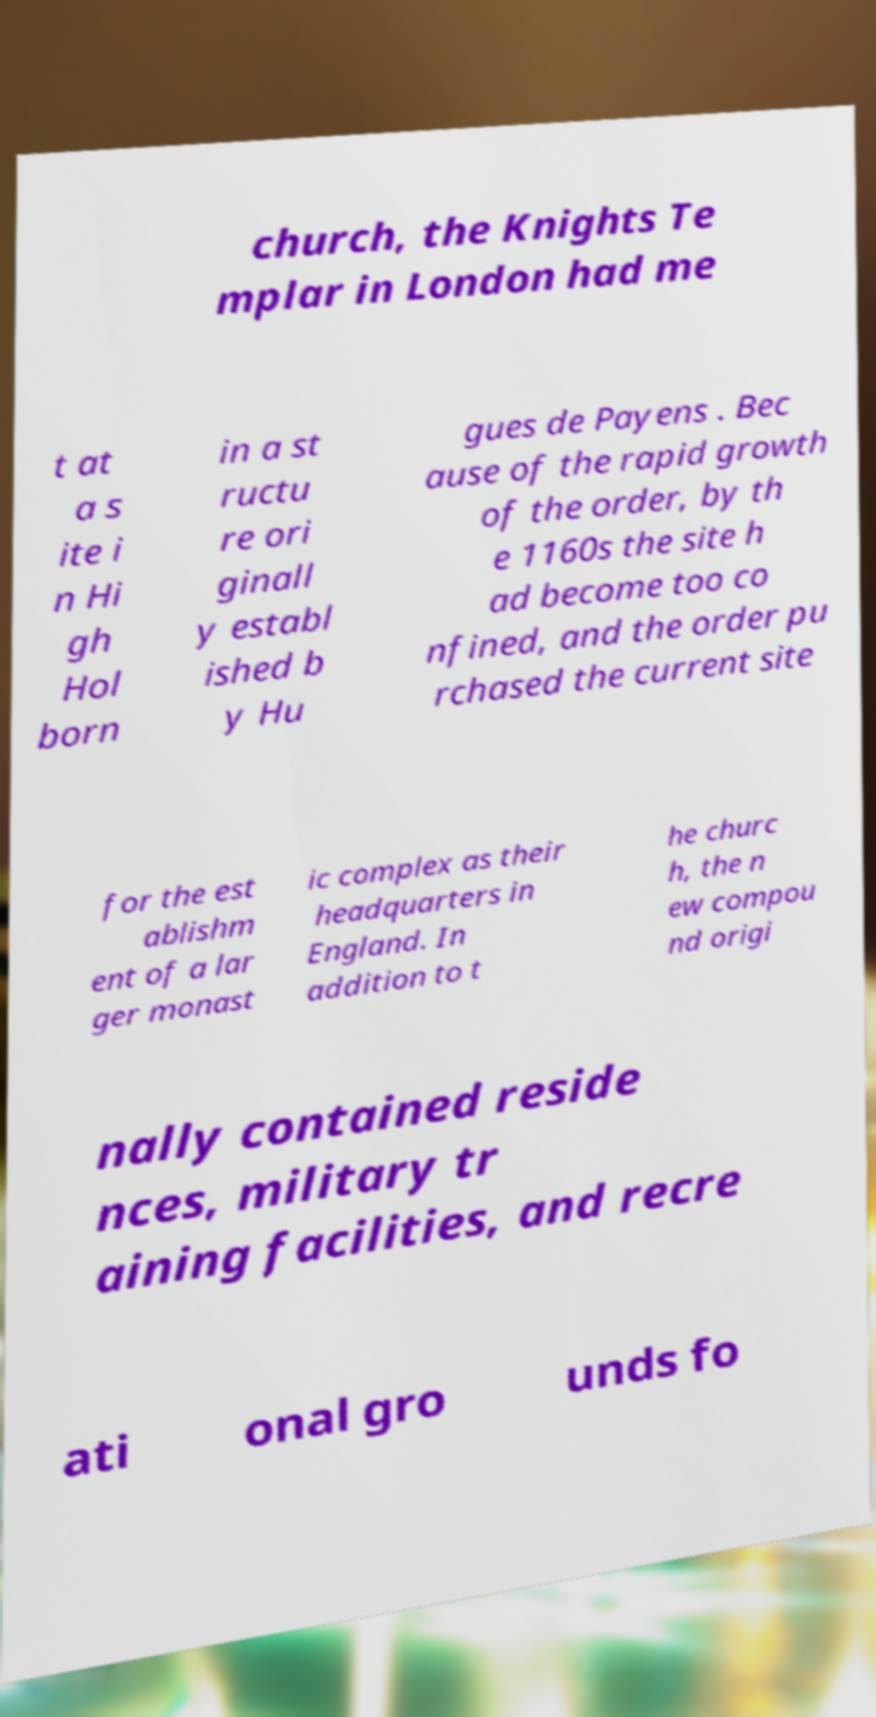Please read and relay the text visible in this image. What does it say? church, the Knights Te mplar in London had me t at a s ite i n Hi gh Hol born in a st ructu re ori ginall y establ ished b y Hu gues de Payens . Bec ause of the rapid growth of the order, by th e 1160s the site h ad become too co nfined, and the order pu rchased the current site for the est ablishm ent of a lar ger monast ic complex as their headquarters in England. In addition to t he churc h, the n ew compou nd origi nally contained reside nces, military tr aining facilities, and recre ati onal gro unds fo 